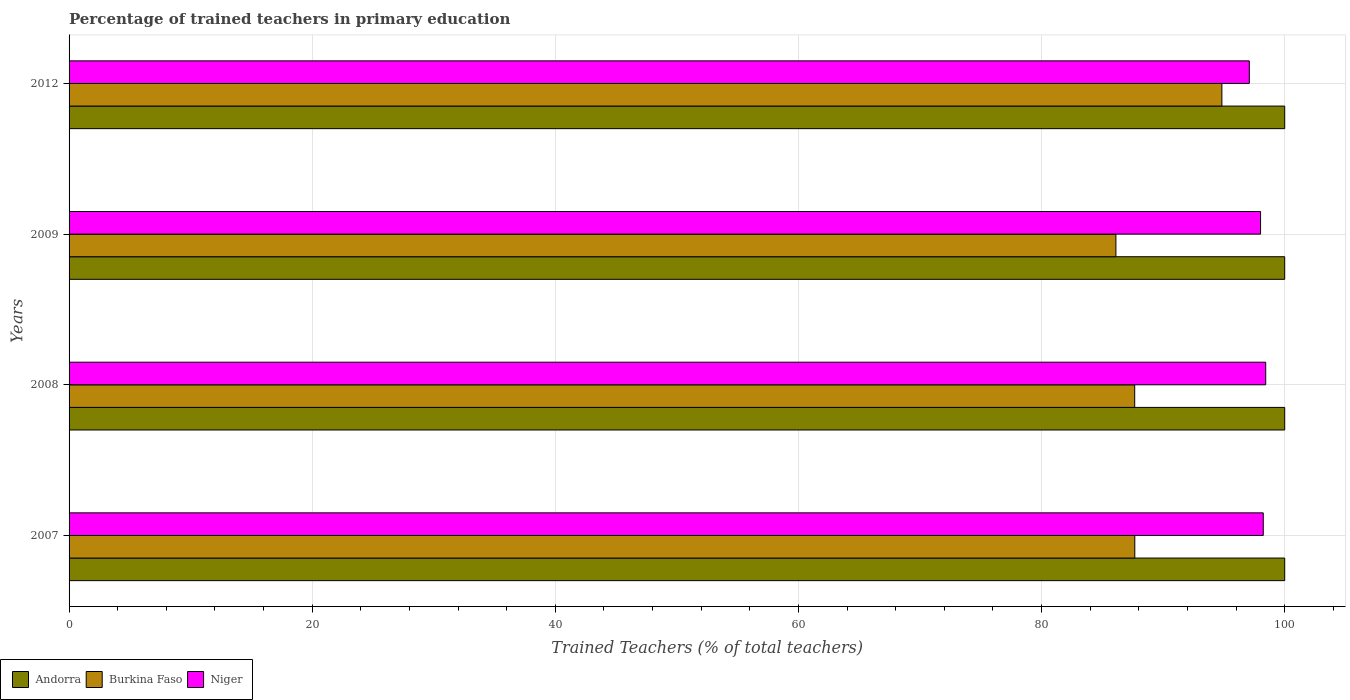How many bars are there on the 2nd tick from the top?
Offer a very short reply. 3. How many bars are there on the 2nd tick from the bottom?
Your answer should be compact. 3. What is the percentage of trained teachers in Burkina Faso in 2012?
Provide a short and direct response. 94.83. Across all years, what is the maximum percentage of trained teachers in Niger?
Ensure brevity in your answer.  98.44. Across all years, what is the minimum percentage of trained teachers in Niger?
Your answer should be compact. 97.09. What is the total percentage of trained teachers in Niger in the graph?
Your answer should be compact. 391.78. What is the difference between the percentage of trained teachers in Niger in 2009 and that in 2012?
Provide a succinct answer. 0.93. What is the difference between the percentage of trained teachers in Niger in 2008 and the percentage of trained teachers in Burkina Faso in 2007?
Provide a succinct answer. 10.77. What is the average percentage of trained teachers in Burkina Faso per year?
Provide a succinct answer. 89.07. In the year 2009, what is the difference between the percentage of trained teachers in Niger and percentage of trained teachers in Andorra?
Your answer should be very brief. -1.99. In how many years, is the percentage of trained teachers in Burkina Faso greater than 84 %?
Offer a terse response. 4. What is the ratio of the percentage of trained teachers in Burkina Faso in 2007 to that in 2008?
Offer a terse response. 1. What is the difference between the highest and the second highest percentage of trained teachers in Niger?
Offer a terse response. 0.2. What is the difference between the highest and the lowest percentage of trained teachers in Andorra?
Offer a terse response. 0. Is the sum of the percentage of trained teachers in Niger in 2009 and 2012 greater than the maximum percentage of trained teachers in Andorra across all years?
Ensure brevity in your answer.  Yes. What does the 2nd bar from the top in 2012 represents?
Keep it short and to the point. Burkina Faso. What does the 2nd bar from the bottom in 2012 represents?
Offer a terse response. Burkina Faso. Does the graph contain any zero values?
Ensure brevity in your answer.  No. Where does the legend appear in the graph?
Ensure brevity in your answer.  Bottom left. What is the title of the graph?
Your response must be concise. Percentage of trained teachers in primary education. Does "Austria" appear as one of the legend labels in the graph?
Keep it short and to the point. No. What is the label or title of the X-axis?
Provide a short and direct response. Trained Teachers (% of total teachers). What is the Trained Teachers (% of total teachers) in Burkina Faso in 2007?
Your answer should be very brief. 87.67. What is the Trained Teachers (% of total teachers) in Niger in 2007?
Offer a terse response. 98.24. What is the Trained Teachers (% of total teachers) in Andorra in 2008?
Your response must be concise. 100. What is the Trained Teachers (% of total teachers) in Burkina Faso in 2008?
Ensure brevity in your answer.  87.66. What is the Trained Teachers (% of total teachers) of Niger in 2008?
Your response must be concise. 98.44. What is the Trained Teachers (% of total teachers) of Burkina Faso in 2009?
Your answer should be compact. 86.11. What is the Trained Teachers (% of total teachers) of Niger in 2009?
Ensure brevity in your answer.  98.01. What is the Trained Teachers (% of total teachers) in Andorra in 2012?
Offer a terse response. 100. What is the Trained Teachers (% of total teachers) of Burkina Faso in 2012?
Provide a succinct answer. 94.83. What is the Trained Teachers (% of total teachers) in Niger in 2012?
Your answer should be very brief. 97.09. Across all years, what is the maximum Trained Teachers (% of total teachers) of Andorra?
Offer a very short reply. 100. Across all years, what is the maximum Trained Teachers (% of total teachers) in Burkina Faso?
Your response must be concise. 94.83. Across all years, what is the maximum Trained Teachers (% of total teachers) in Niger?
Make the answer very short. 98.44. Across all years, what is the minimum Trained Teachers (% of total teachers) of Burkina Faso?
Your response must be concise. 86.11. Across all years, what is the minimum Trained Teachers (% of total teachers) in Niger?
Offer a very short reply. 97.09. What is the total Trained Teachers (% of total teachers) of Burkina Faso in the graph?
Your answer should be very brief. 356.28. What is the total Trained Teachers (% of total teachers) in Niger in the graph?
Your answer should be compact. 391.78. What is the difference between the Trained Teachers (% of total teachers) of Burkina Faso in 2007 and that in 2008?
Offer a very short reply. 0.01. What is the difference between the Trained Teachers (% of total teachers) in Niger in 2007 and that in 2008?
Offer a very short reply. -0.2. What is the difference between the Trained Teachers (% of total teachers) of Andorra in 2007 and that in 2009?
Make the answer very short. 0. What is the difference between the Trained Teachers (% of total teachers) in Burkina Faso in 2007 and that in 2009?
Keep it short and to the point. 1.55. What is the difference between the Trained Teachers (% of total teachers) of Niger in 2007 and that in 2009?
Offer a very short reply. 0.22. What is the difference between the Trained Teachers (% of total teachers) in Andorra in 2007 and that in 2012?
Keep it short and to the point. 0. What is the difference between the Trained Teachers (% of total teachers) of Burkina Faso in 2007 and that in 2012?
Offer a terse response. -7.16. What is the difference between the Trained Teachers (% of total teachers) of Niger in 2007 and that in 2012?
Your answer should be very brief. 1.15. What is the difference between the Trained Teachers (% of total teachers) of Burkina Faso in 2008 and that in 2009?
Your answer should be compact. 1.55. What is the difference between the Trained Teachers (% of total teachers) of Niger in 2008 and that in 2009?
Give a very brief answer. 0.42. What is the difference between the Trained Teachers (% of total teachers) in Andorra in 2008 and that in 2012?
Make the answer very short. 0. What is the difference between the Trained Teachers (% of total teachers) of Burkina Faso in 2008 and that in 2012?
Provide a succinct answer. -7.17. What is the difference between the Trained Teachers (% of total teachers) in Niger in 2008 and that in 2012?
Keep it short and to the point. 1.35. What is the difference between the Trained Teachers (% of total teachers) in Andorra in 2009 and that in 2012?
Your answer should be very brief. 0. What is the difference between the Trained Teachers (% of total teachers) of Burkina Faso in 2009 and that in 2012?
Give a very brief answer. -8.72. What is the difference between the Trained Teachers (% of total teachers) of Niger in 2009 and that in 2012?
Give a very brief answer. 0.93. What is the difference between the Trained Teachers (% of total teachers) of Andorra in 2007 and the Trained Teachers (% of total teachers) of Burkina Faso in 2008?
Give a very brief answer. 12.34. What is the difference between the Trained Teachers (% of total teachers) of Andorra in 2007 and the Trained Teachers (% of total teachers) of Niger in 2008?
Give a very brief answer. 1.56. What is the difference between the Trained Teachers (% of total teachers) in Burkina Faso in 2007 and the Trained Teachers (% of total teachers) in Niger in 2008?
Provide a short and direct response. -10.77. What is the difference between the Trained Teachers (% of total teachers) of Andorra in 2007 and the Trained Teachers (% of total teachers) of Burkina Faso in 2009?
Your response must be concise. 13.89. What is the difference between the Trained Teachers (% of total teachers) in Andorra in 2007 and the Trained Teachers (% of total teachers) in Niger in 2009?
Offer a very short reply. 1.99. What is the difference between the Trained Teachers (% of total teachers) of Burkina Faso in 2007 and the Trained Teachers (% of total teachers) of Niger in 2009?
Give a very brief answer. -10.35. What is the difference between the Trained Teachers (% of total teachers) of Andorra in 2007 and the Trained Teachers (% of total teachers) of Burkina Faso in 2012?
Your response must be concise. 5.17. What is the difference between the Trained Teachers (% of total teachers) of Andorra in 2007 and the Trained Teachers (% of total teachers) of Niger in 2012?
Your response must be concise. 2.91. What is the difference between the Trained Teachers (% of total teachers) in Burkina Faso in 2007 and the Trained Teachers (% of total teachers) in Niger in 2012?
Your answer should be very brief. -9.42. What is the difference between the Trained Teachers (% of total teachers) of Andorra in 2008 and the Trained Teachers (% of total teachers) of Burkina Faso in 2009?
Offer a terse response. 13.89. What is the difference between the Trained Teachers (% of total teachers) of Andorra in 2008 and the Trained Teachers (% of total teachers) of Niger in 2009?
Your response must be concise. 1.99. What is the difference between the Trained Teachers (% of total teachers) of Burkina Faso in 2008 and the Trained Teachers (% of total teachers) of Niger in 2009?
Your answer should be compact. -10.35. What is the difference between the Trained Teachers (% of total teachers) in Andorra in 2008 and the Trained Teachers (% of total teachers) in Burkina Faso in 2012?
Provide a succinct answer. 5.17. What is the difference between the Trained Teachers (% of total teachers) in Andorra in 2008 and the Trained Teachers (% of total teachers) in Niger in 2012?
Give a very brief answer. 2.91. What is the difference between the Trained Teachers (% of total teachers) in Burkina Faso in 2008 and the Trained Teachers (% of total teachers) in Niger in 2012?
Offer a terse response. -9.43. What is the difference between the Trained Teachers (% of total teachers) in Andorra in 2009 and the Trained Teachers (% of total teachers) in Burkina Faso in 2012?
Make the answer very short. 5.17. What is the difference between the Trained Teachers (% of total teachers) in Andorra in 2009 and the Trained Teachers (% of total teachers) in Niger in 2012?
Provide a short and direct response. 2.91. What is the difference between the Trained Teachers (% of total teachers) of Burkina Faso in 2009 and the Trained Teachers (% of total teachers) of Niger in 2012?
Keep it short and to the point. -10.97. What is the average Trained Teachers (% of total teachers) in Andorra per year?
Your answer should be compact. 100. What is the average Trained Teachers (% of total teachers) in Burkina Faso per year?
Your response must be concise. 89.07. What is the average Trained Teachers (% of total teachers) of Niger per year?
Provide a short and direct response. 97.94. In the year 2007, what is the difference between the Trained Teachers (% of total teachers) in Andorra and Trained Teachers (% of total teachers) in Burkina Faso?
Keep it short and to the point. 12.33. In the year 2007, what is the difference between the Trained Teachers (% of total teachers) of Andorra and Trained Teachers (% of total teachers) of Niger?
Your response must be concise. 1.76. In the year 2007, what is the difference between the Trained Teachers (% of total teachers) in Burkina Faso and Trained Teachers (% of total teachers) in Niger?
Offer a very short reply. -10.57. In the year 2008, what is the difference between the Trained Teachers (% of total teachers) in Andorra and Trained Teachers (% of total teachers) in Burkina Faso?
Offer a terse response. 12.34. In the year 2008, what is the difference between the Trained Teachers (% of total teachers) of Andorra and Trained Teachers (% of total teachers) of Niger?
Ensure brevity in your answer.  1.56. In the year 2008, what is the difference between the Trained Teachers (% of total teachers) in Burkina Faso and Trained Teachers (% of total teachers) in Niger?
Make the answer very short. -10.78. In the year 2009, what is the difference between the Trained Teachers (% of total teachers) in Andorra and Trained Teachers (% of total teachers) in Burkina Faso?
Your answer should be very brief. 13.89. In the year 2009, what is the difference between the Trained Teachers (% of total teachers) in Andorra and Trained Teachers (% of total teachers) in Niger?
Your answer should be very brief. 1.99. In the year 2009, what is the difference between the Trained Teachers (% of total teachers) in Burkina Faso and Trained Teachers (% of total teachers) in Niger?
Your response must be concise. -11.9. In the year 2012, what is the difference between the Trained Teachers (% of total teachers) of Andorra and Trained Teachers (% of total teachers) of Burkina Faso?
Offer a very short reply. 5.17. In the year 2012, what is the difference between the Trained Teachers (% of total teachers) in Andorra and Trained Teachers (% of total teachers) in Niger?
Provide a succinct answer. 2.91. In the year 2012, what is the difference between the Trained Teachers (% of total teachers) of Burkina Faso and Trained Teachers (% of total teachers) of Niger?
Offer a terse response. -2.26. What is the ratio of the Trained Teachers (% of total teachers) of Burkina Faso in 2007 to that in 2008?
Your answer should be compact. 1. What is the ratio of the Trained Teachers (% of total teachers) of Niger in 2007 to that in 2008?
Make the answer very short. 1. What is the ratio of the Trained Teachers (% of total teachers) of Andorra in 2007 to that in 2012?
Your answer should be compact. 1. What is the ratio of the Trained Teachers (% of total teachers) in Burkina Faso in 2007 to that in 2012?
Offer a very short reply. 0.92. What is the ratio of the Trained Teachers (% of total teachers) of Niger in 2007 to that in 2012?
Your answer should be very brief. 1.01. What is the ratio of the Trained Teachers (% of total teachers) of Burkina Faso in 2008 to that in 2012?
Offer a very short reply. 0.92. What is the ratio of the Trained Teachers (% of total teachers) in Niger in 2008 to that in 2012?
Make the answer very short. 1.01. What is the ratio of the Trained Teachers (% of total teachers) of Andorra in 2009 to that in 2012?
Your answer should be compact. 1. What is the ratio of the Trained Teachers (% of total teachers) of Burkina Faso in 2009 to that in 2012?
Your answer should be very brief. 0.91. What is the ratio of the Trained Teachers (% of total teachers) of Niger in 2009 to that in 2012?
Make the answer very short. 1.01. What is the difference between the highest and the second highest Trained Teachers (% of total teachers) of Andorra?
Make the answer very short. 0. What is the difference between the highest and the second highest Trained Teachers (% of total teachers) in Burkina Faso?
Provide a short and direct response. 7.16. What is the difference between the highest and the second highest Trained Teachers (% of total teachers) of Niger?
Ensure brevity in your answer.  0.2. What is the difference between the highest and the lowest Trained Teachers (% of total teachers) of Andorra?
Offer a very short reply. 0. What is the difference between the highest and the lowest Trained Teachers (% of total teachers) of Burkina Faso?
Offer a terse response. 8.72. What is the difference between the highest and the lowest Trained Teachers (% of total teachers) in Niger?
Provide a short and direct response. 1.35. 